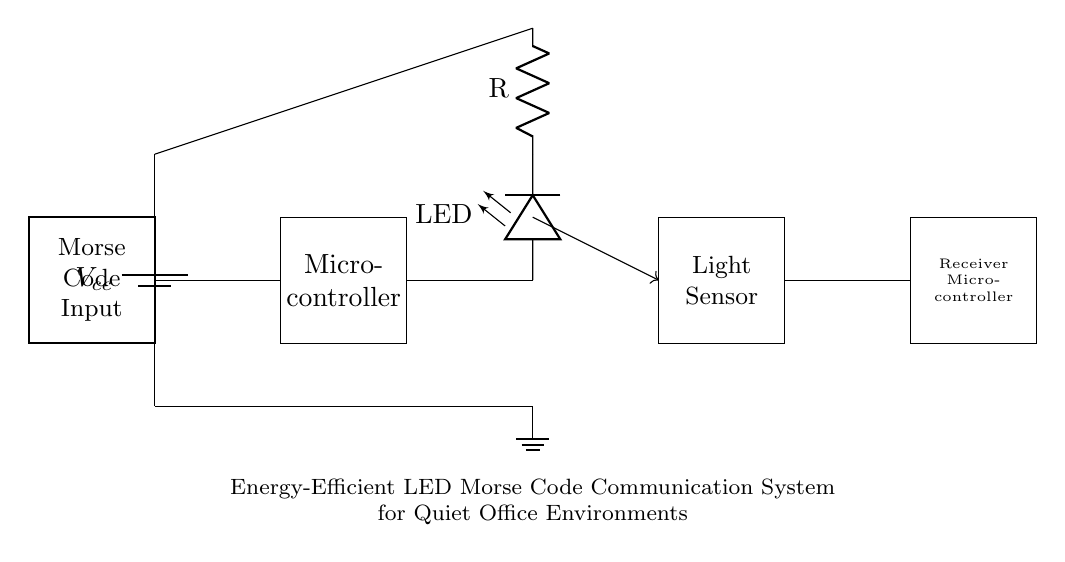What is the power supply type used in this circuit? The circuit uses a battery as indicated by the "battery1" label connected at the beginning of the circuit diagram. Batteries provide a direct current power supply to the circuit.
Answer: Battery What function does the microcontroller serve in this circuit? The microcontroller processes the Morse code input and controls the LED output. It's the central unit that interprets signals and manages data flow based on programming.
Answer: Control What type of sensor is shown in this circuit? The light sensor is identified as a component in the receiver section of the diagram, which detects the state of the LED light signal sent as Morse code.
Answer: Light sensor How many microcontrollers are present in the circuit? There are two microcontrollers: one is for processing the Morse code input and the other is for receiving signals from the light sensor.
Answer: Two What is the purpose of the resistor connected to the LED? The resistor limits the current passing through the LED to prevent it from burning out, ensuring it operates safely within its specifications.
Answer: Current limiting Which components are connected in series in this circuit? The LED and the resistor are connected in series after the microcontroller, allowing the same current to flow through both components.
Answer: LED and resistor What is the primary application of this communication system? The energy-efficient LED Morse code communication system is designed specifically for use in quiet office environments, allowing discreet communication through light signals.
Answer: Quiet communication 